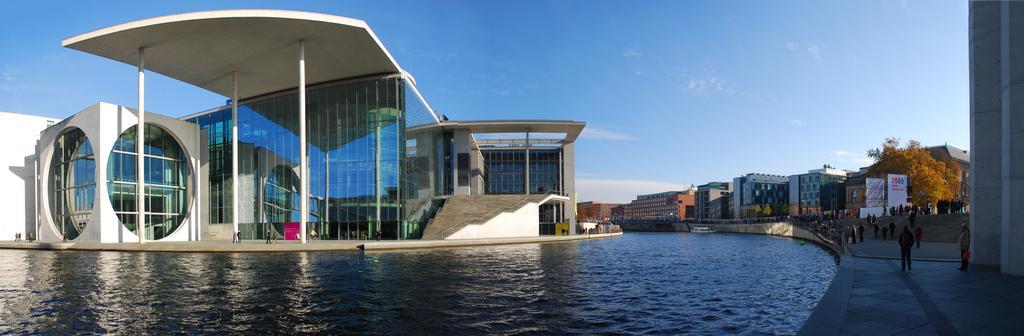Please provide a concise description of this image. In this image we can see buildings, poles, hoardings, trees, pillars, and people. There is a boat on the water. In the background there is sky with clouds. 